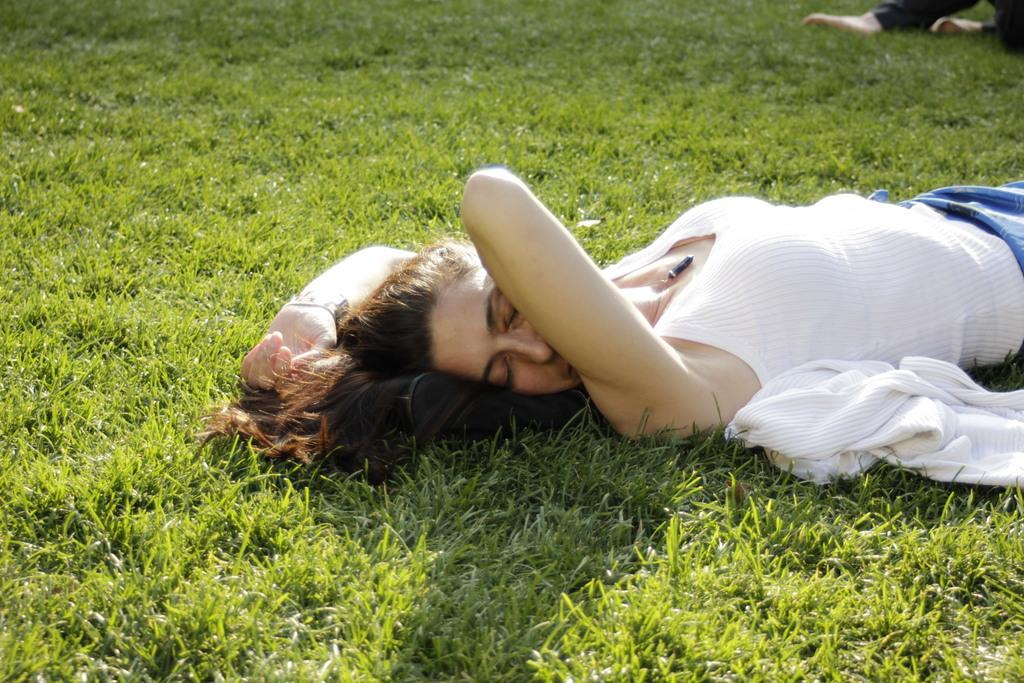What is present in the image? There is a person, cloth, an object, and grass in the background of the image. Can you describe the person in the image? A person's legs are visible on the right side top of the image. What is the object in the image? The facts do not specify the nature of the object, so we cannot describe it. What is the background of the image? There is grass in the background of the image. Is there a ghost involved in a fight in the image? There is no mention of a ghost or a fight in the image. The image features a person, cloth, an object, and grass in the background. 